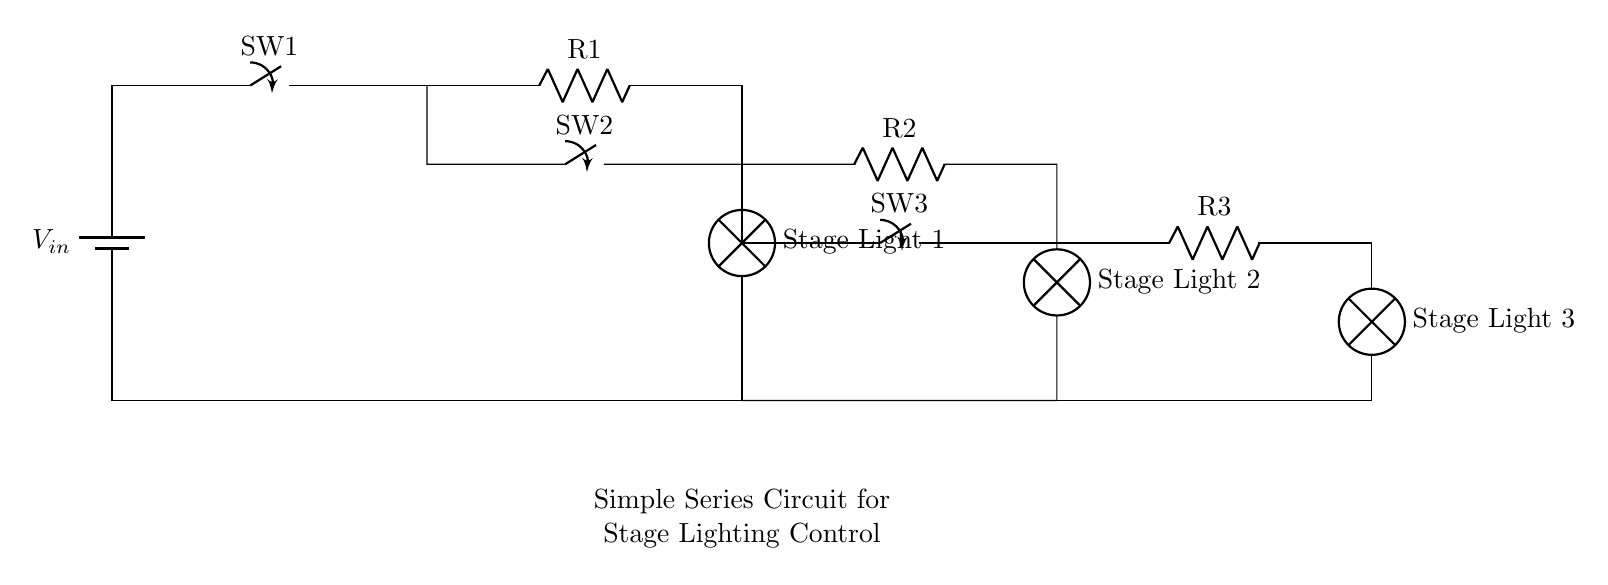What is the total number of switches in this circuit? The circuit diagram shows three distinct switch symbols (SW1, SW2, and SW3) labeled along the paths of the circuit, indicating that there are three switches controlling the circuit.
Answer: three What components are used in this circuit? The circuit consists of a battery, three switches, three resistors, and three lamps. Each of these components can be identified by their unique symbols and labels in the diagram.
Answer: battery, switches, resistors, lamps How many lamps are present in the circuit? The diagram displays three lamp symbols, each labeled as "Stage Light 1," "Stage Light 2," and "Stage Light 3," confirming that there are three lamps connected in this circuit.
Answer: three What happens to the current if one switch is turned off? In a series circuit, the current flows through all components in a single pathway. If one switch is turned off, it breaks the circuit, preventing current from flowing to all lamps and making them turn off.
Answer: It stops What is the arrangement of the resistors in this circuit? The resistors are arranged in series, meaning they are connected one after another in a single path. This is evident as the output of one resistor connects directly to the next component without any branching.
Answer: series What is the role of the switches in this circuit? The switches control the flow of electricity in the circuit. When a switch is closed, it completes the circuit pathway, allowing current to flow and light the corresponding lamp. When opened, it interrupts the flow, turning off the lamp.
Answer: Control current flow 